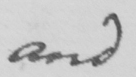What does this handwritten line say? and 